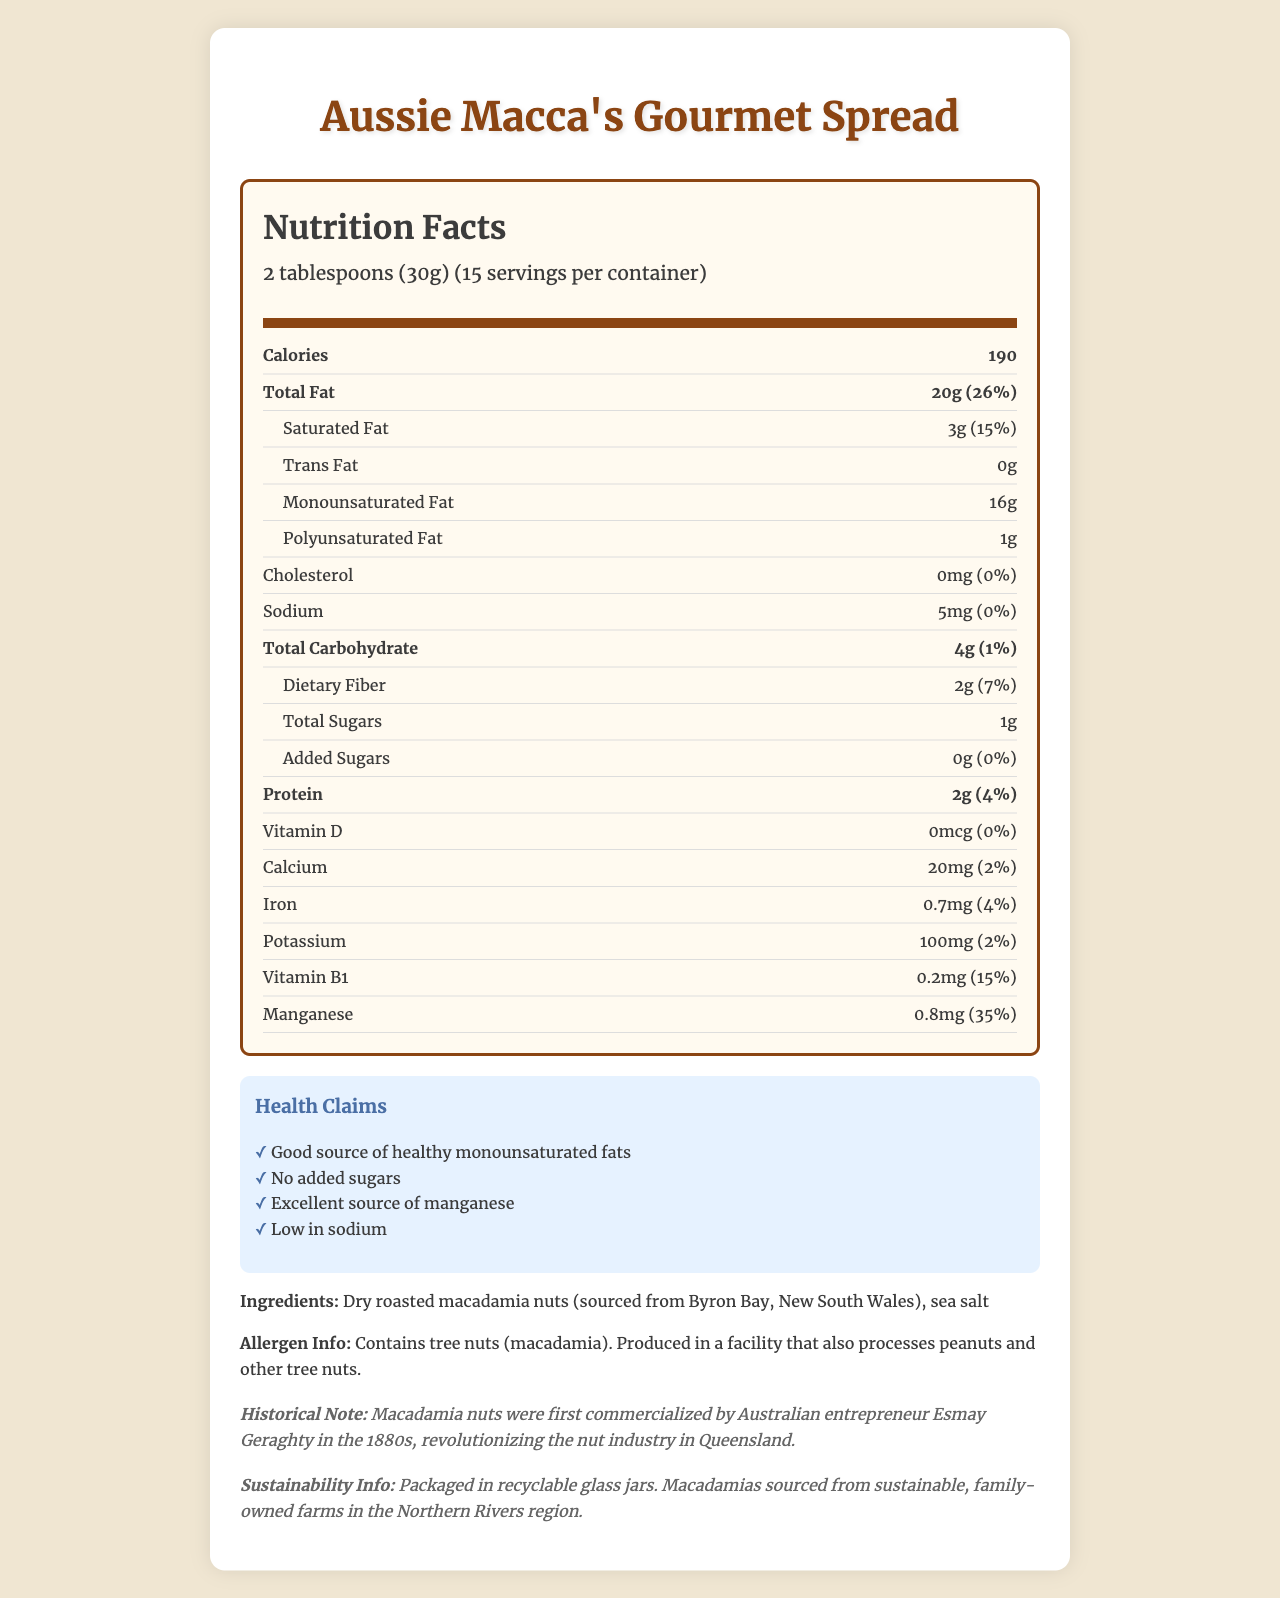Who commercialized macadamia nuts in the 1880s? The historical note mentions that macadamia nuts were first commercialized by the Australian entrepreneur Esmay Geraghty in the 1880s.
Answer: Esmay Geraghty What is the serving size of Aussie Macca's Gourmet Spread? The document states that the serving size is 2 tablespoons (30g).
Answer: 2 tablespoons (30g) How much monounsaturated fat is in one serving of the spread? The nutrition label specifies that one serving of the spread contains 16g of monounsaturated fat.
Answer: 16g What is the daily value percentage of saturated fat in one serving? The saturated fat section of the nutrition label lists the daily value percentage as 15%.
Answer: 15% What nutrient is the spread an excellent source of, according to the health claims? The health claims section includes "Excellent source of manganese" as one of the claims.
Answer: Manganese What is the main ingredient in Aussie Macca's Gourmet Spread? The ingredients list states that the main ingredient is dry roasted macadamia nuts from Byron Bay, New South Wales.
Answer: Dry roasted macadamia nuts What is the amount of protein in one serving of this spread? The protein amount per serving is listed as 2g on the nutrition label.
Answer: 2g Which of the following is NOT included in the health claims? A. Contains added sugars B. Good source of healthy monounsaturated fats C. Low in sodium D. No added sugars The health claims do not include "Contains added sugars"; in fact, it mentions "No added sugars".
Answer: A Which vitamin or mineral has the highest daily value percentage in the spread? A. Calcium B. Iron C. Vitamin B1 D. Manganese Manganese has the highest daily value percentage at 35%.
Answer: D Is this product low in sodium? The document explicitly lists "Low in sodium" in the health claims section.
Answer: Yes Does this spread contain any cholesterol? The nutrition label specifies that the cholesterol amount is 0mg, which corresponds to a daily value of 0%.
Answer: No Summarize the main features of the document. The document details the nutritional content, health benefits, and historical and sustainability information about the product. It provides a comprehensive overview of the nutritional values, ingredients, allergen info, and historical notes.
Answer: Aussie Macca's Gourmet Spread is a gourmet Australian macadamia nut spread with a serving size of 2 tablespoons (30g). It contains 190 calories per serving, with 20g of total fat, of which 16g are monounsaturated fats. The spread is low in sodium (5mg) and has no cholesterol or added sugars. It is an excellent source of manganese and also provides other nutrients like protein, vitamin B1, and iron. Historically, the spread acknowledges the contribution of Esmay Geraghty to the commercialization of macadamia nuts. The product is sustainably sourced and packaged. What is the exact year Esmay Geraghty started commercializing macadamia nuts? The document specifies the 1880s but does not give an exact year for when Esmay Geraghty started commercializing macadamia nuts.
Answer: Not enough information How many grams of polyunsaturated fat are in the entire container? The document doesn’t provide the information to calculate the total amount of polyunsaturated fat in the entire container directly.
Answer: N/A 